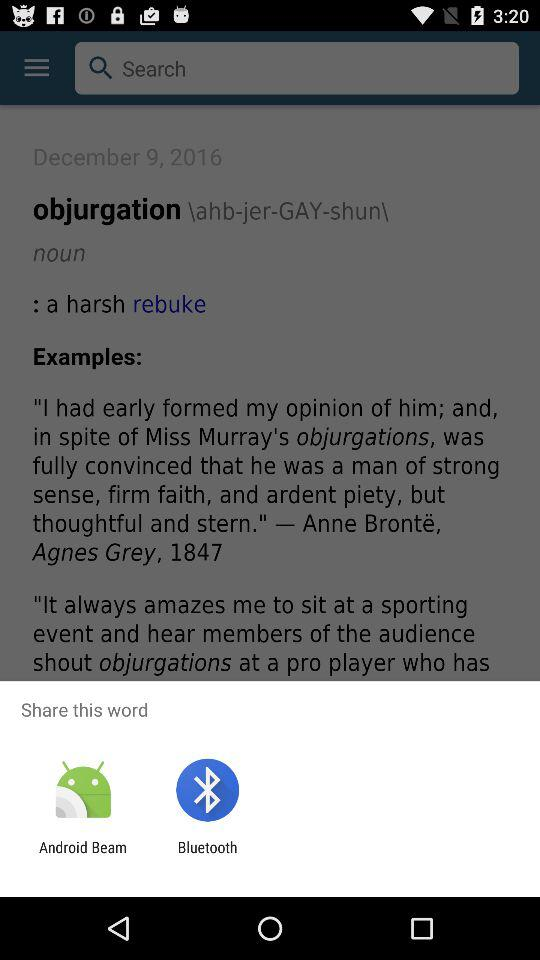How many examples are there?
Answer the question using a single word or phrase. 2 